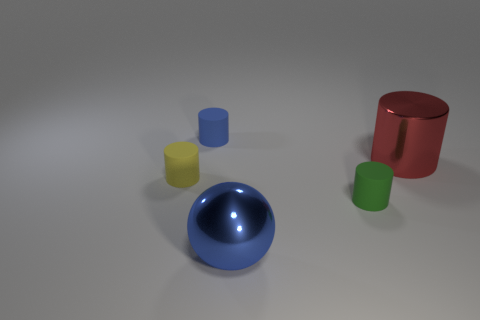There is a tiny object that is both in front of the red metallic cylinder and on the left side of the small green thing; what shape is it? The tiny object in question appears to be a yellow cylinder. It is positioned in front of the red cylinder and to the left of the small, green cylinder when viewed from the camera’s perspective in the image. 